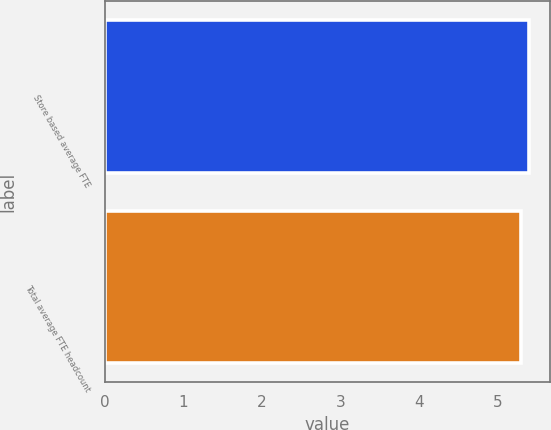Convert chart. <chart><loc_0><loc_0><loc_500><loc_500><bar_chart><fcel>Store based average FTE<fcel>Total average FTE headcount<nl><fcel>5.4<fcel>5.3<nl></chart> 